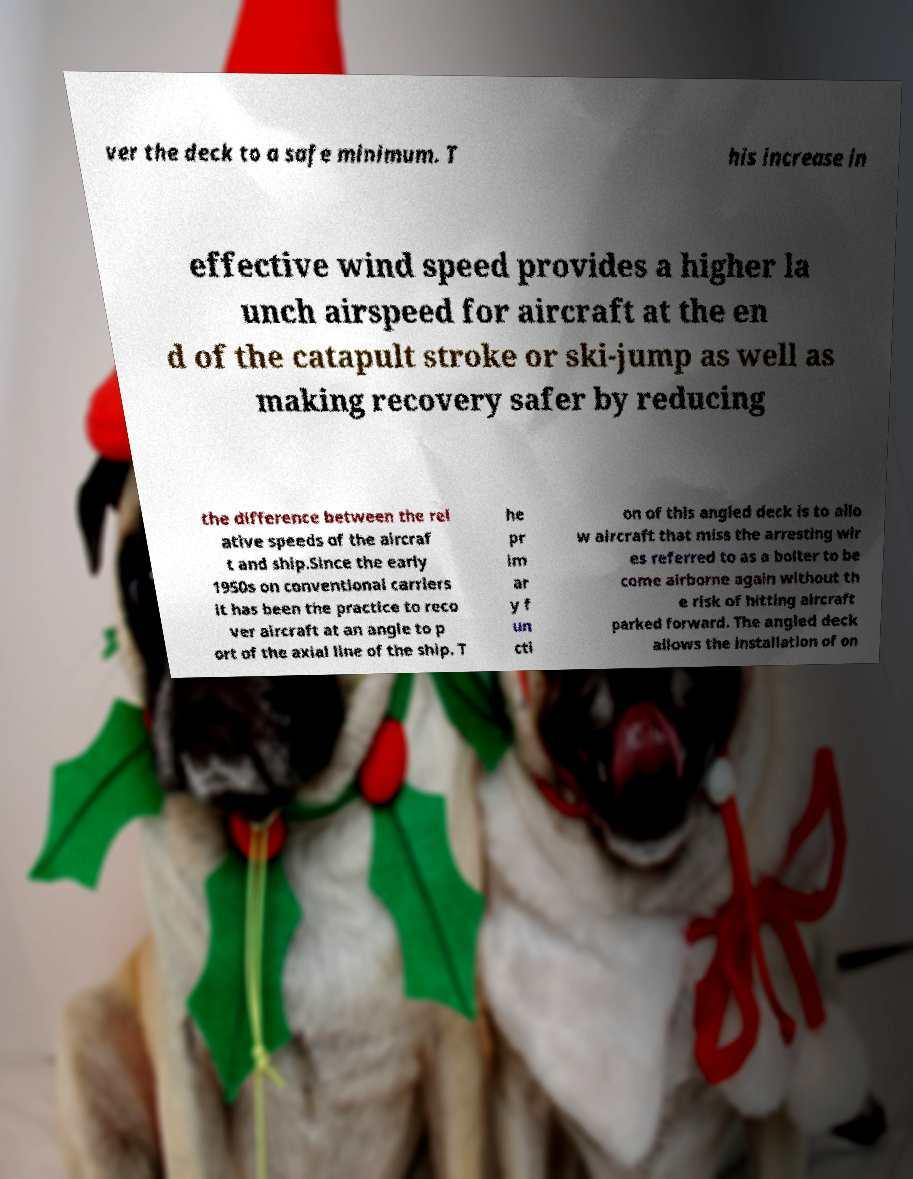Can you accurately transcribe the text from the provided image for me? ver the deck to a safe minimum. T his increase in effective wind speed provides a higher la unch airspeed for aircraft at the en d of the catapult stroke or ski-jump as well as making recovery safer by reducing the difference between the rel ative speeds of the aircraf t and ship.Since the early 1950s on conventional carriers it has been the practice to reco ver aircraft at an angle to p ort of the axial line of the ship. T he pr im ar y f un cti on of this angled deck is to allo w aircraft that miss the arresting wir es referred to as a bolter to be come airborne again without th e risk of hitting aircraft parked forward. The angled deck allows the installation of on 